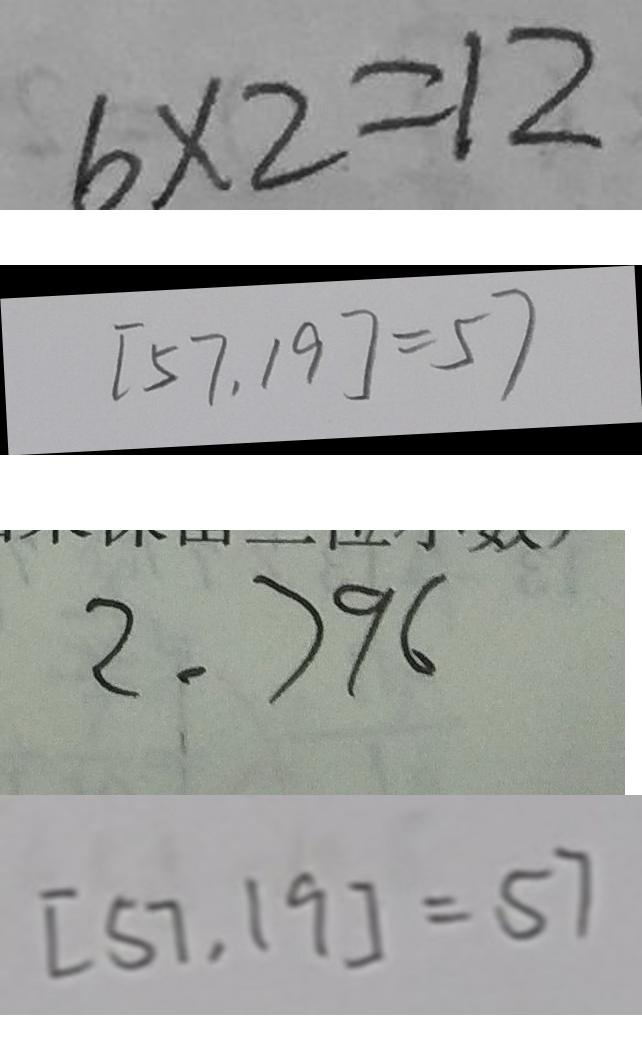Convert formula to latex. <formula><loc_0><loc_0><loc_500><loc_500>6 \times 2 = 1 2 
 [ 5 7 , 1 9 ] = 5 7 
 2 . 7 9 6 
 [ 5 7 , 1 9 ] = 5 7</formula> 